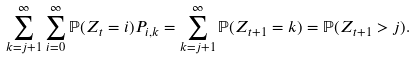Convert formula to latex. <formula><loc_0><loc_0><loc_500><loc_500>\sum _ { k = j + 1 } ^ { \infty } \sum _ { i = 0 } ^ { \infty } \mathbb { P } ( Z _ { t } = i ) P _ { i , k } = \sum _ { k = j + 1 } ^ { \infty } \mathbb { P } ( Z _ { t + 1 } = k ) = \mathbb { P } ( Z _ { t + 1 } > j ) .</formula> 